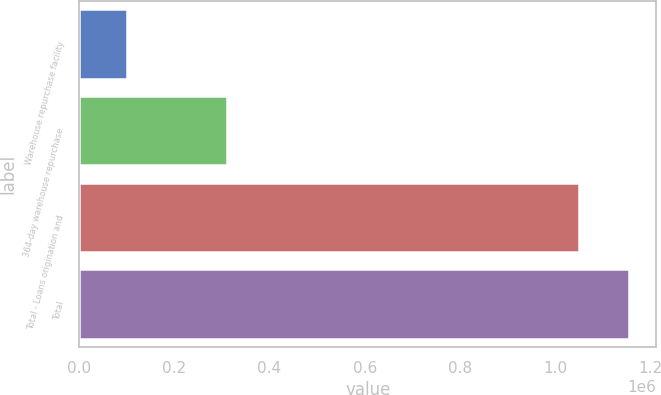Convert chart to OTSL. <chart><loc_0><loc_0><loc_500><loc_500><bar_chart><fcel>Warehouse repurchase facility<fcel>364-day warehouse repurchase<fcel>Total - Loans origination and<fcel>Total<nl><fcel>100000<fcel>310000<fcel>1.05e+06<fcel>1.155e+06<nl></chart> 